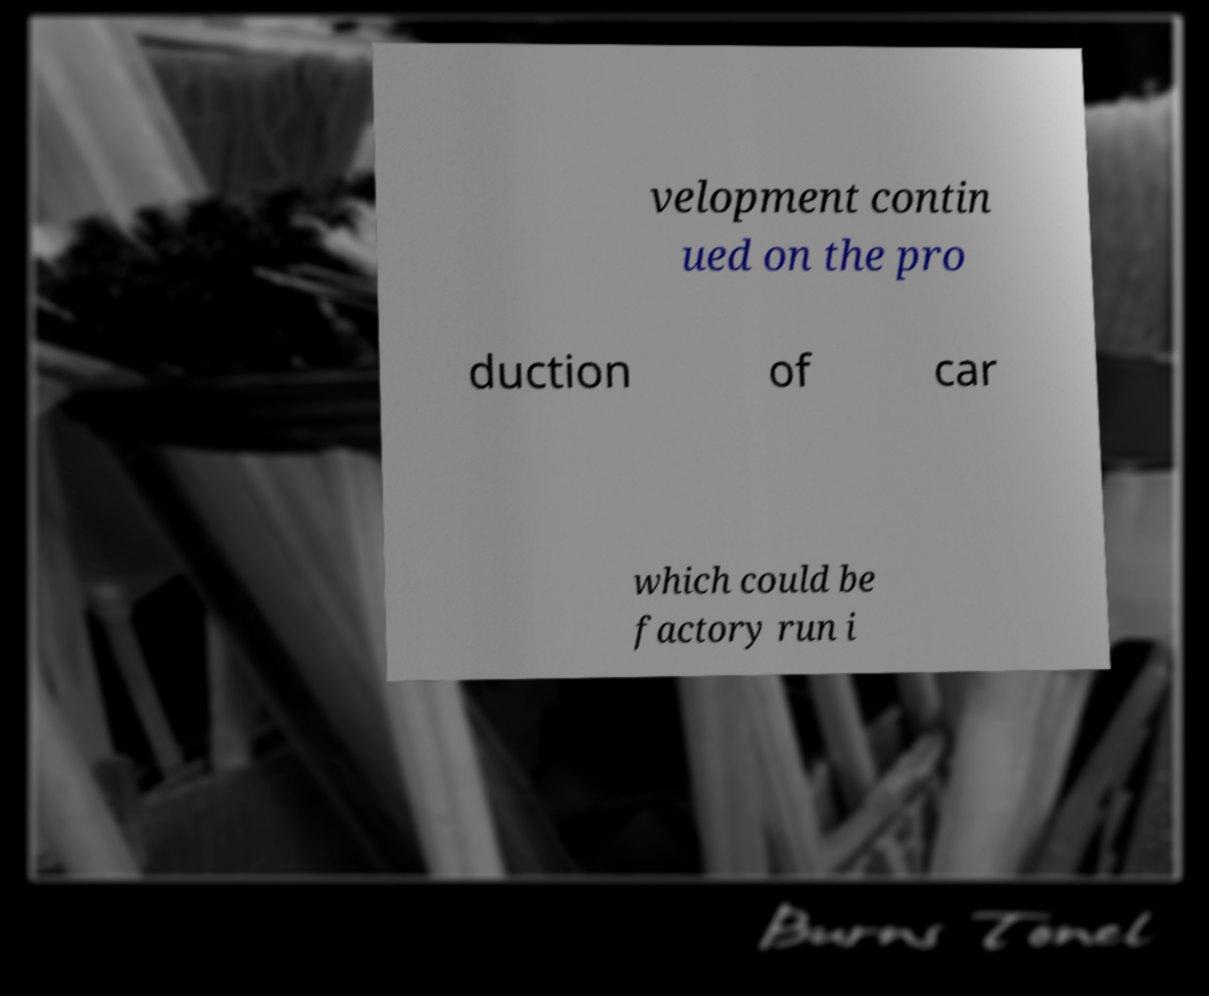Please read and relay the text visible in this image. What does it say? velopment contin ued on the pro duction of car which could be factory run i 